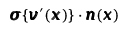Convert formula to latex. <formula><loc_0><loc_0><loc_500><loc_500>{ \pm b \sigma } \{ { \pm b v } ^ { \prime } ( { \pm b x } ) \} \cdot { \pm b n } ( { \pm b x } )</formula> 